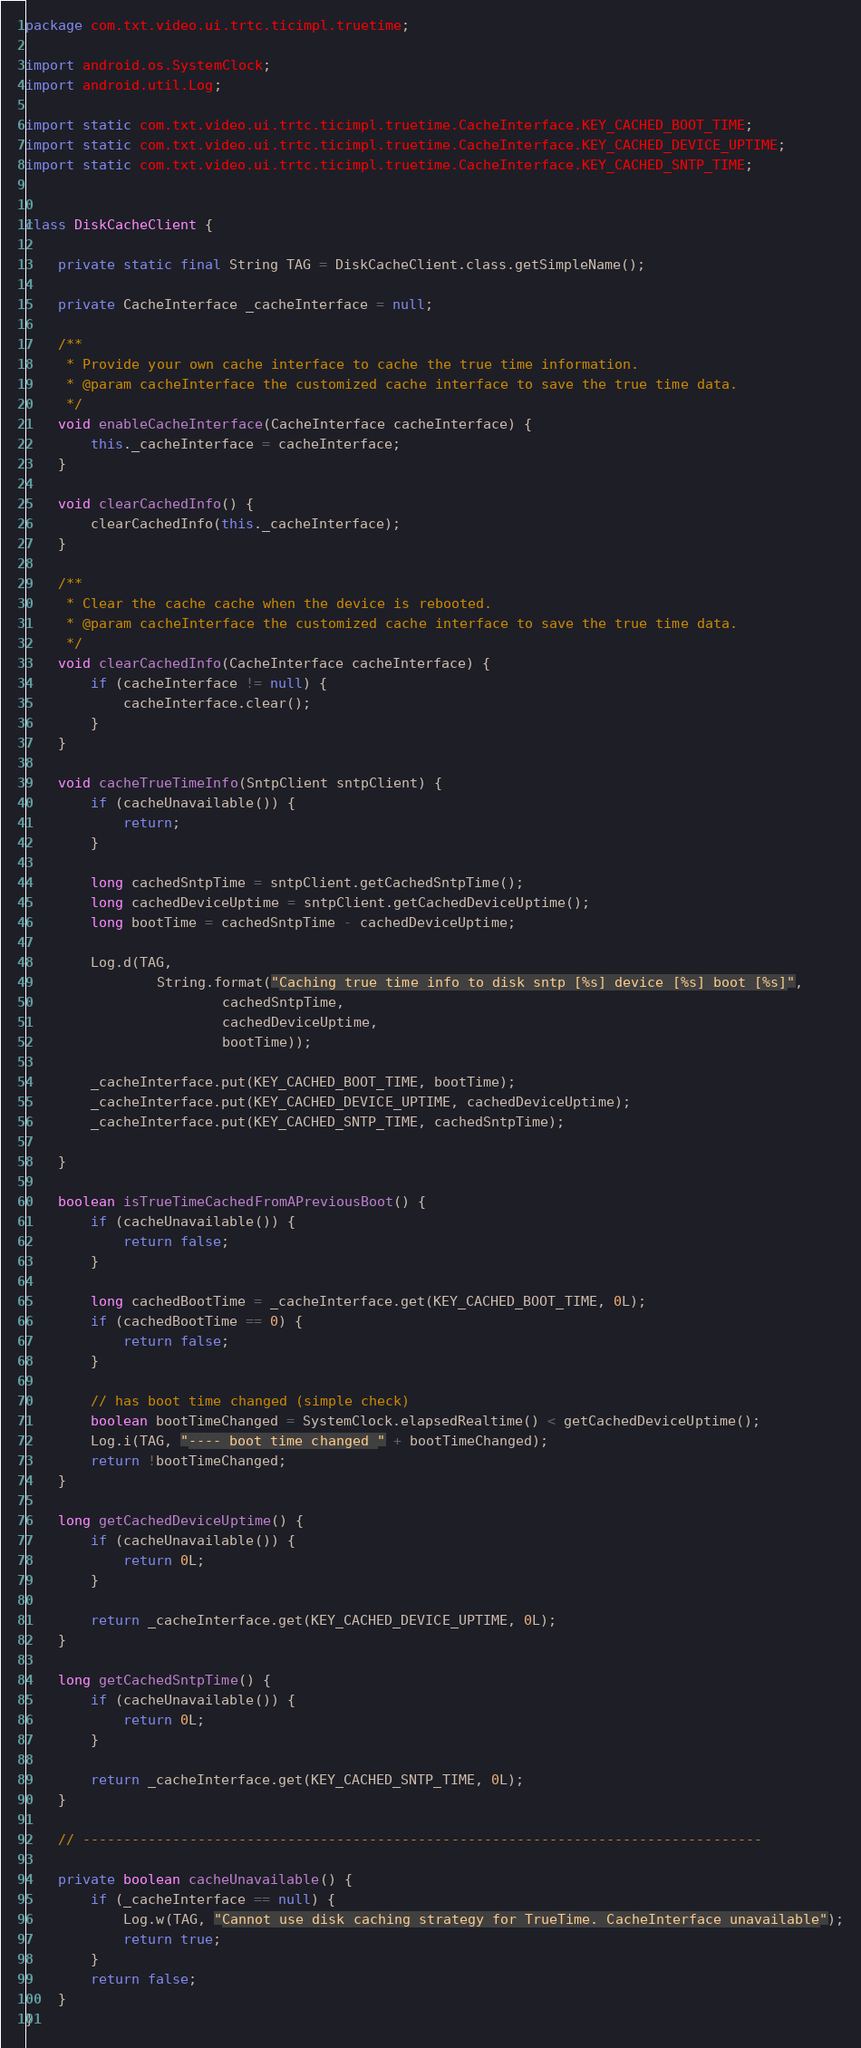Convert code to text. <code><loc_0><loc_0><loc_500><loc_500><_Java_>package com.txt.video.ui.trtc.ticimpl.truetime;

import android.os.SystemClock;
import android.util.Log;

import static com.txt.video.ui.trtc.ticimpl.truetime.CacheInterface.KEY_CACHED_BOOT_TIME;
import static com.txt.video.ui.trtc.ticimpl.truetime.CacheInterface.KEY_CACHED_DEVICE_UPTIME;
import static com.txt.video.ui.trtc.ticimpl.truetime.CacheInterface.KEY_CACHED_SNTP_TIME;


class DiskCacheClient {

    private static final String TAG = DiskCacheClient.class.getSimpleName();

    private CacheInterface _cacheInterface = null;

    /**
     * Provide your own cache interface to cache the true time information.
     * @param cacheInterface the customized cache interface to save the true time data.
     */
    void enableCacheInterface(CacheInterface cacheInterface) {
        this._cacheInterface = cacheInterface;
    }

    void clearCachedInfo() {
        clearCachedInfo(this._cacheInterface);
    }

    /**
     * Clear the cache cache when the device is rebooted.
     * @param cacheInterface the customized cache interface to save the true time data.
     */
    void clearCachedInfo(CacheInterface cacheInterface) {
        if (cacheInterface != null) {
            cacheInterface.clear();
        }
    }

    void cacheTrueTimeInfo(SntpClient sntpClient) {
        if (cacheUnavailable()) {
            return;
        }

        long cachedSntpTime = sntpClient.getCachedSntpTime();
        long cachedDeviceUptime = sntpClient.getCachedDeviceUptime();
        long bootTime = cachedSntpTime - cachedDeviceUptime;

        Log.d(TAG,
                String.format("Caching true time info to disk sntp [%s] device [%s] boot [%s]",
                        cachedSntpTime,
                        cachedDeviceUptime,
                        bootTime));

        _cacheInterface.put(KEY_CACHED_BOOT_TIME, bootTime);
        _cacheInterface.put(KEY_CACHED_DEVICE_UPTIME, cachedDeviceUptime);
        _cacheInterface.put(KEY_CACHED_SNTP_TIME, cachedSntpTime);

    }

    boolean isTrueTimeCachedFromAPreviousBoot() {
        if (cacheUnavailable()) {
            return false;
        }

        long cachedBootTime = _cacheInterface.get(KEY_CACHED_BOOT_TIME, 0L);
        if (cachedBootTime == 0) {
            return false;
        }

        // has boot time changed (simple check)
        boolean bootTimeChanged = SystemClock.elapsedRealtime() < getCachedDeviceUptime();
        Log.i(TAG, "---- boot time changed " + bootTimeChanged);
        return !bootTimeChanged;
    }

    long getCachedDeviceUptime() {
        if (cacheUnavailable()) {
            return 0L;
        }

        return _cacheInterface.get(KEY_CACHED_DEVICE_UPTIME, 0L);
    }

    long getCachedSntpTime() {
        if (cacheUnavailable()) {
            return 0L;
        }

        return _cacheInterface.get(KEY_CACHED_SNTP_TIME, 0L);
    }

    // -----------------------------------------------------------------------------------

    private boolean cacheUnavailable() {
        if (_cacheInterface == null) {
            Log.w(TAG, "Cannot use disk caching strategy for TrueTime. CacheInterface unavailable");
            return true;
        }
        return false;
    }
}
</code> 